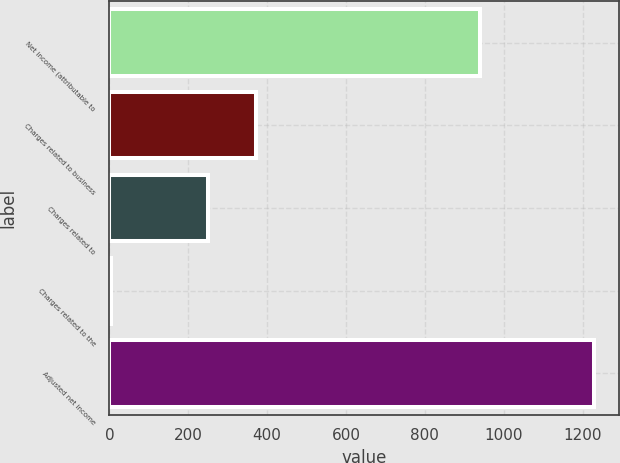<chart> <loc_0><loc_0><loc_500><loc_500><bar_chart><fcel>Net income (attributable to<fcel>Charges related to business<fcel>Charges related to<fcel>Charges related to the<fcel>Adjusted net income<nl><fcel>941<fcel>371.8<fcel>249.2<fcel>4<fcel>1230<nl></chart> 